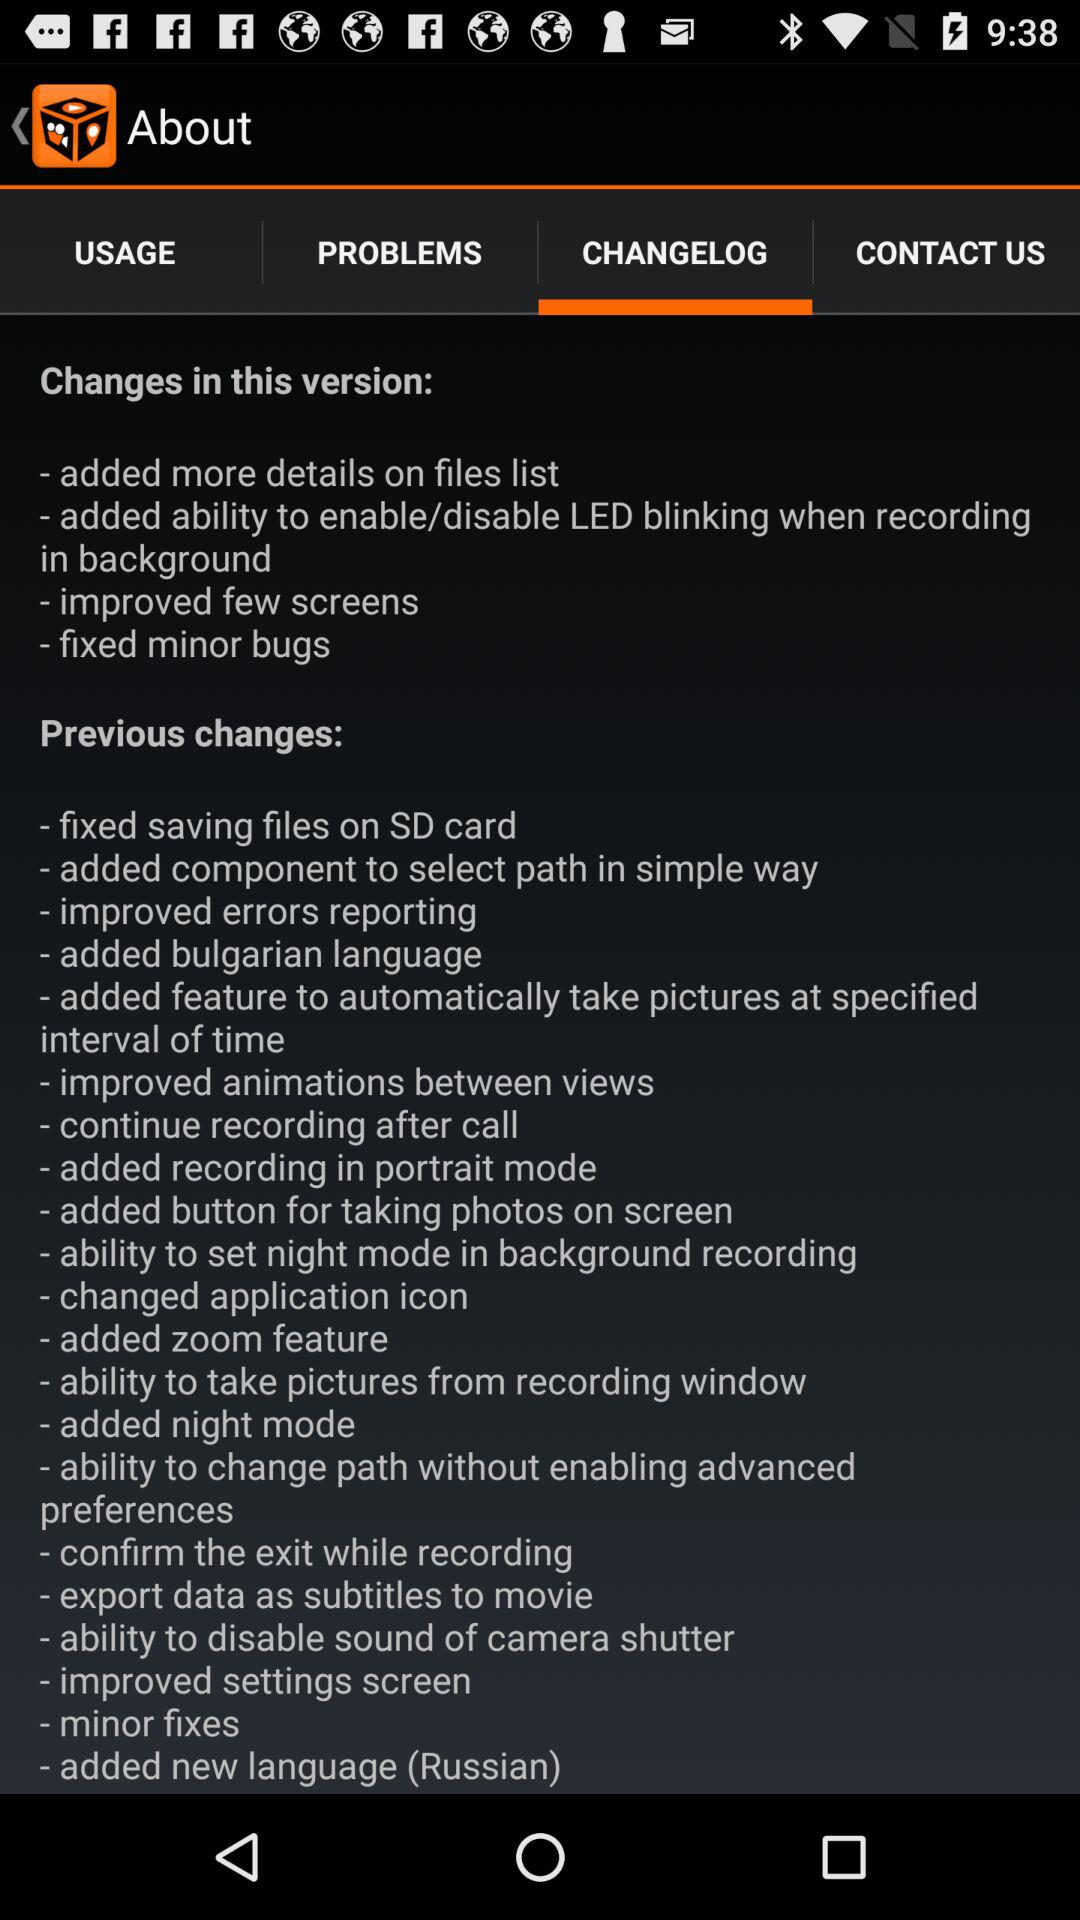How can the application provider be contacted?
When the provided information is insufficient, respond with <no answer>. <no answer> 